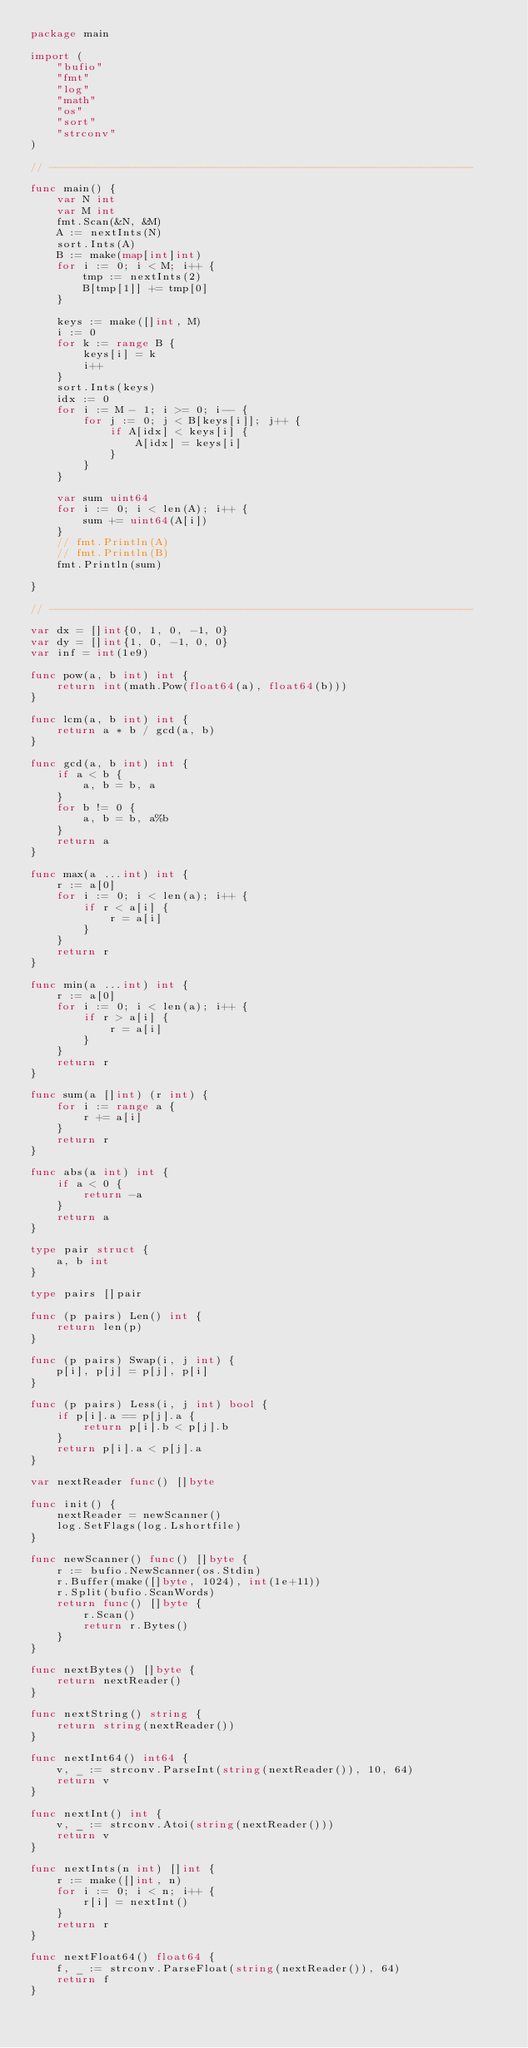Convert code to text. <code><loc_0><loc_0><loc_500><loc_500><_Go_>package main

import (
	"bufio"
	"fmt"
	"log"
	"math"
	"os"
	"sort"
	"strconv"
)

// ----------------------------------------------------------------

func main() {
	var N int
	var M int
	fmt.Scan(&N, &M)
	A := nextInts(N)
	sort.Ints(A)
	B := make(map[int]int)
	for i := 0; i < M; i++ {
		tmp := nextInts(2)
		B[tmp[1]] += tmp[0]
	}

	keys := make([]int, M)
	i := 0
	for k := range B {
		keys[i] = k
		i++
	}
	sort.Ints(keys)
	idx := 0
	for i := M - 1; i >= 0; i-- {
		for j := 0; j < B[keys[i]]; j++ {
			if A[idx] < keys[i] {
				A[idx] = keys[i]
			}
		}
	}

	var sum uint64
	for i := 0; i < len(A); i++ {
		sum += uint64(A[i])
	}
	// fmt.Println(A)
	// fmt.Println(B)
	fmt.Println(sum)

}

// ----------------------------------------------------------------

var dx = []int{0, 1, 0, -1, 0}
var dy = []int{1, 0, -1, 0, 0}
var inf = int(1e9)

func pow(a, b int) int {
	return int(math.Pow(float64(a), float64(b)))
}

func lcm(a, b int) int {
	return a * b / gcd(a, b)
}

func gcd(a, b int) int {
	if a < b {
		a, b = b, a
	}
	for b != 0 {
		a, b = b, a%b
	}
	return a
}

func max(a ...int) int {
	r := a[0]
	for i := 0; i < len(a); i++ {
		if r < a[i] {
			r = a[i]
		}
	}
	return r
}

func min(a ...int) int {
	r := a[0]
	for i := 0; i < len(a); i++ {
		if r > a[i] {
			r = a[i]
		}
	}
	return r
}

func sum(a []int) (r int) {
	for i := range a {
		r += a[i]
	}
	return r
}

func abs(a int) int {
	if a < 0 {
		return -a
	}
	return a
}

type pair struct {
	a, b int
}

type pairs []pair

func (p pairs) Len() int {
	return len(p)
}

func (p pairs) Swap(i, j int) {
	p[i], p[j] = p[j], p[i]
}

func (p pairs) Less(i, j int) bool {
	if p[i].a == p[j].a {
		return p[i].b < p[j].b
	}
	return p[i].a < p[j].a
}

var nextReader func() []byte

func init() {
	nextReader = newScanner()
	log.SetFlags(log.Lshortfile)
}

func newScanner() func() []byte {
	r := bufio.NewScanner(os.Stdin)
	r.Buffer(make([]byte, 1024), int(1e+11))
	r.Split(bufio.ScanWords)
	return func() []byte {
		r.Scan()
		return r.Bytes()
	}
}

func nextBytes() []byte {
	return nextReader()
}

func nextString() string {
	return string(nextReader())
}

func nextInt64() int64 {
	v, _ := strconv.ParseInt(string(nextReader()), 10, 64)
	return v
}

func nextInt() int {
	v, _ := strconv.Atoi(string(nextReader()))
	return v
}

func nextInts(n int) []int {
	r := make([]int, n)
	for i := 0; i < n; i++ {
		r[i] = nextInt()
	}
	return r
}

func nextFloat64() float64 {
	f, _ := strconv.ParseFloat(string(nextReader()), 64)
	return f
}
</code> 